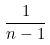Convert formula to latex. <formula><loc_0><loc_0><loc_500><loc_500>\frac { 1 } { n - 1 }</formula> 